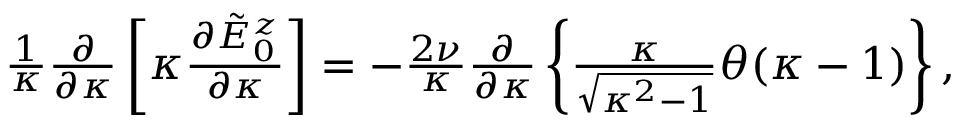Convert formula to latex. <formula><loc_0><loc_0><loc_500><loc_500>\begin{array} { r } { \frac { 1 } { \kappa } \frac { \partial } { \partial \kappa } \left [ \kappa \frac { \partial \tilde { E } _ { 0 } ^ { z } } { \partial \kappa } \right ] = - \frac { 2 \nu } { \kappa } \frac { \partial } { \partial \kappa } \left \{ \frac { \kappa } { \sqrt { \kappa ^ { 2 } - 1 } } \theta ( \kappa - 1 ) \right \} , } \end{array}</formula> 